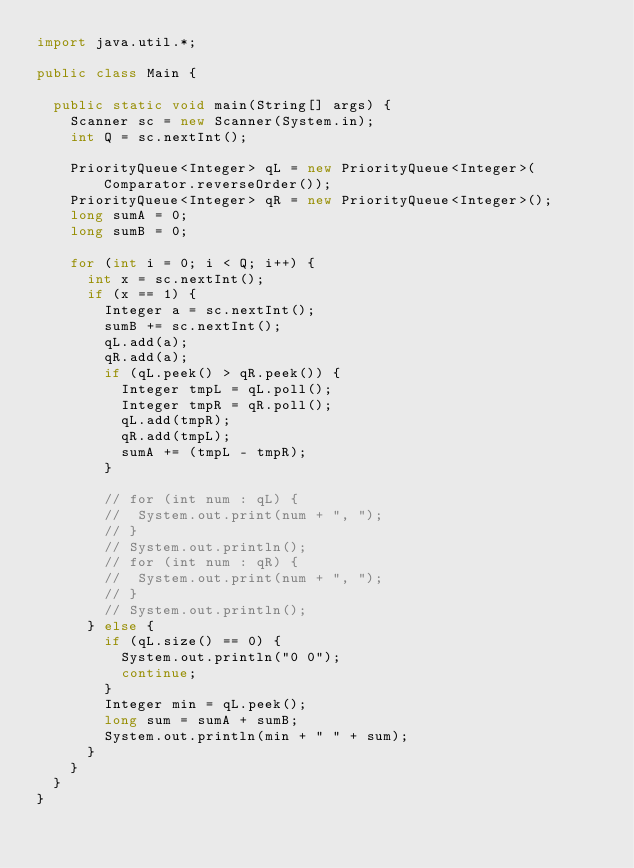<code> <loc_0><loc_0><loc_500><loc_500><_Java_>import java.util.*;

public class Main {

	public static void main(String[] args) {
		Scanner sc = new Scanner(System.in);
		int Q = sc.nextInt();

		PriorityQueue<Integer> qL = new PriorityQueue<Integer>(Comparator.reverseOrder());
		PriorityQueue<Integer> qR = new PriorityQueue<Integer>();
		long sumA = 0;
		long sumB = 0;

		for (int i = 0; i < Q; i++) {
			int x = sc.nextInt();
			if (x == 1) {
				Integer a = sc.nextInt();
				sumB += sc.nextInt();
				qL.add(a);
				qR.add(a);
				if (qL.peek() > qR.peek()) {
					Integer tmpL = qL.poll();
					Integer tmpR = qR.poll();
					qL.add(tmpR);
					qR.add(tmpL);
					sumA += (tmpL - tmpR);
				}

				// for (int num : qL) {
				// 	System.out.print(num + ", ");
				// }
				// System.out.println();
				// for (int num : qR) {
				// 	System.out.print(num + ", ");
				// }
				// System.out.println();
			} else {
				if (qL.size() == 0) {
					System.out.println("0 0");
					continue;
				}
				Integer min = qL.peek();
				long sum = sumA + sumB;
				System.out.println(min + " " + sum);
			}
		}
	}
}
</code> 